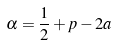<formula> <loc_0><loc_0><loc_500><loc_500>\alpha = \frac { 1 } { 2 } + p - 2 a</formula> 